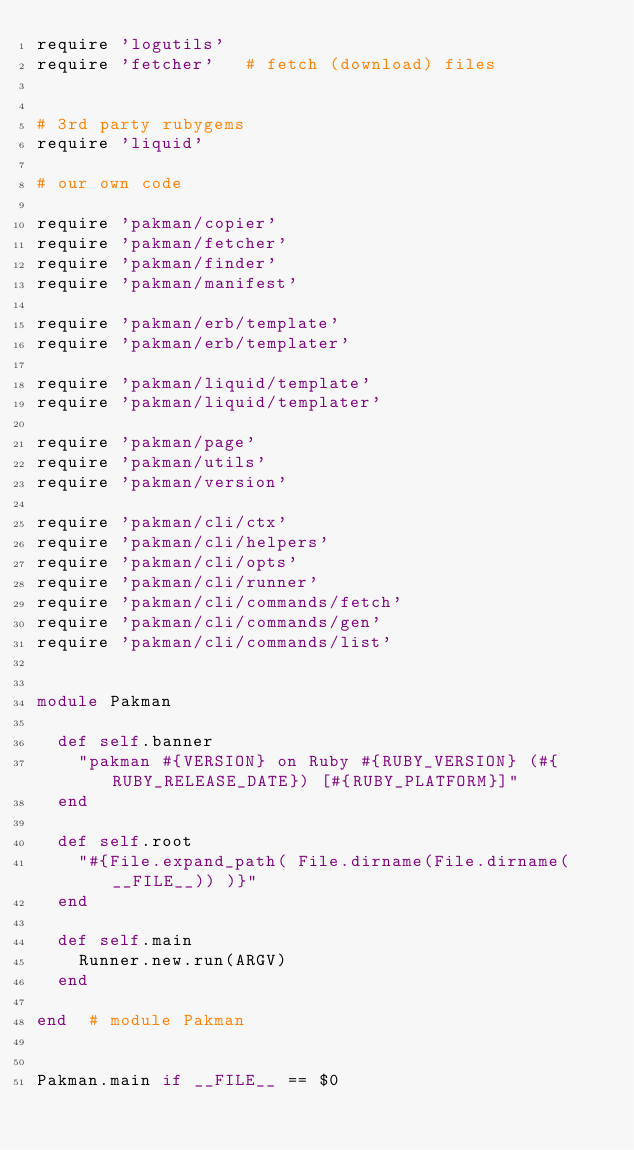<code> <loc_0><loc_0><loc_500><loc_500><_Ruby_>require 'logutils'
require 'fetcher'   # fetch (download) files


# 3rd party rubygems
require 'liquid'

# our own code

require 'pakman/copier'
require 'pakman/fetcher'
require 'pakman/finder'
require 'pakman/manifest'

require 'pakman/erb/template'
require 'pakman/erb/templater'

require 'pakman/liquid/template'
require 'pakman/liquid/templater'

require 'pakman/page'
require 'pakman/utils'
require 'pakman/version'

require 'pakman/cli/ctx'
require 'pakman/cli/helpers'
require 'pakman/cli/opts'
require 'pakman/cli/runner'
require 'pakman/cli/commands/fetch'
require 'pakman/cli/commands/gen'
require 'pakman/cli/commands/list'


module Pakman

  def self.banner
    "pakman #{VERSION} on Ruby #{RUBY_VERSION} (#{RUBY_RELEASE_DATE}) [#{RUBY_PLATFORM}]"
  end

  def self.root
    "#{File.expand_path( File.dirname(File.dirname(__FILE__)) )}"
  end

  def self.main
    Runner.new.run(ARGV)
  end

end  # module Pakman


Pakman.main if __FILE__ == $0
</code> 